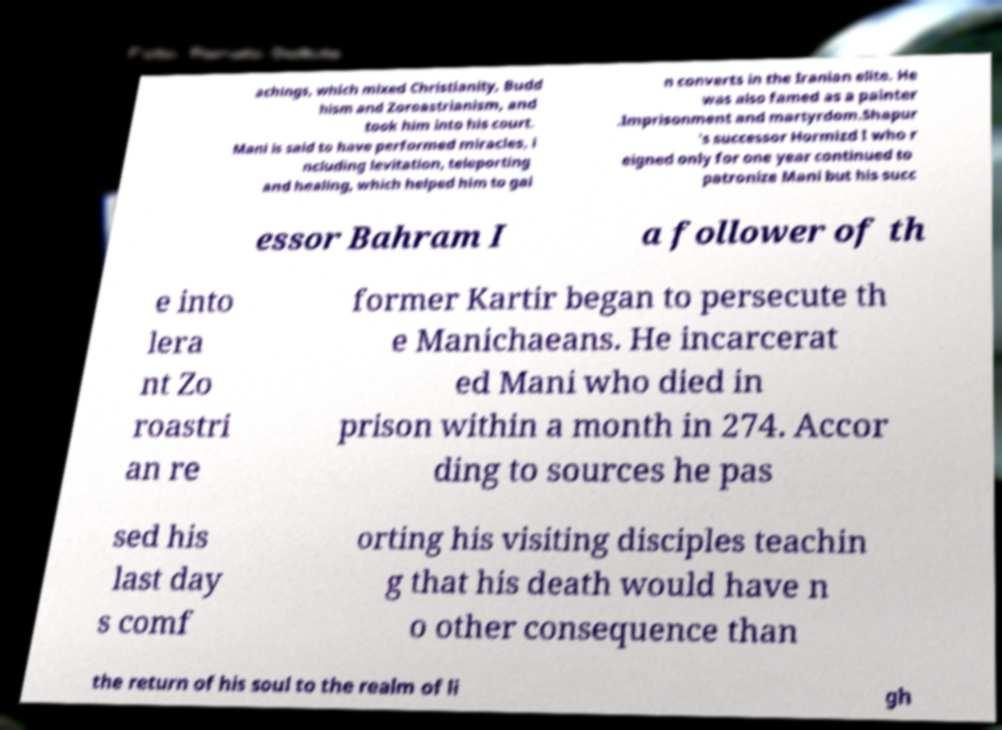There's text embedded in this image that I need extracted. Can you transcribe it verbatim? achings, which mixed Christianity, Budd hism and Zoroastrianism, and took him into his court. Mani is said to have performed miracles, i ncluding levitation, teleporting and healing, which helped him to gai n converts in the Iranian elite. He was also famed as a painter .Imprisonment and martyrdom.Shapur 's successor Hormizd I who r eigned only for one year continued to patronize Mani but his succ essor Bahram I a follower of th e into lera nt Zo roastri an re former Kartir began to persecute th e Manichaeans. He incarcerat ed Mani who died in prison within a month in 274. Accor ding to sources he pas sed his last day s comf orting his visiting disciples teachin g that his death would have n o other consequence than the return of his soul to the realm of li gh 